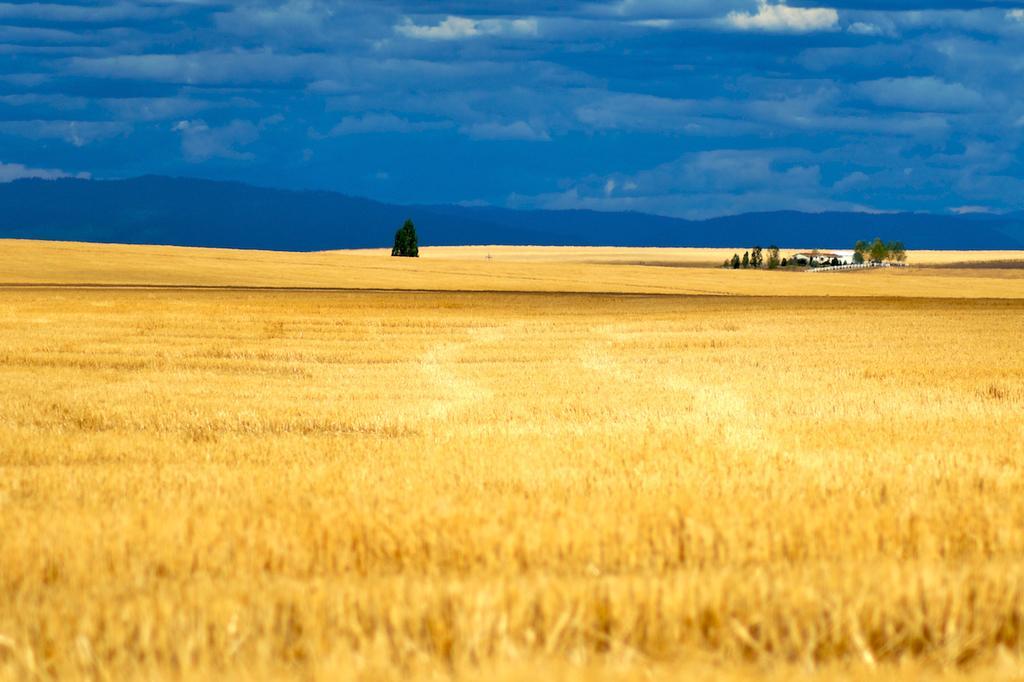Please provide a concise description of this image. In this image I can see the dried grass and the grass is in brown color. Background I can see few trees in green color and the sky is in blue and white color. 